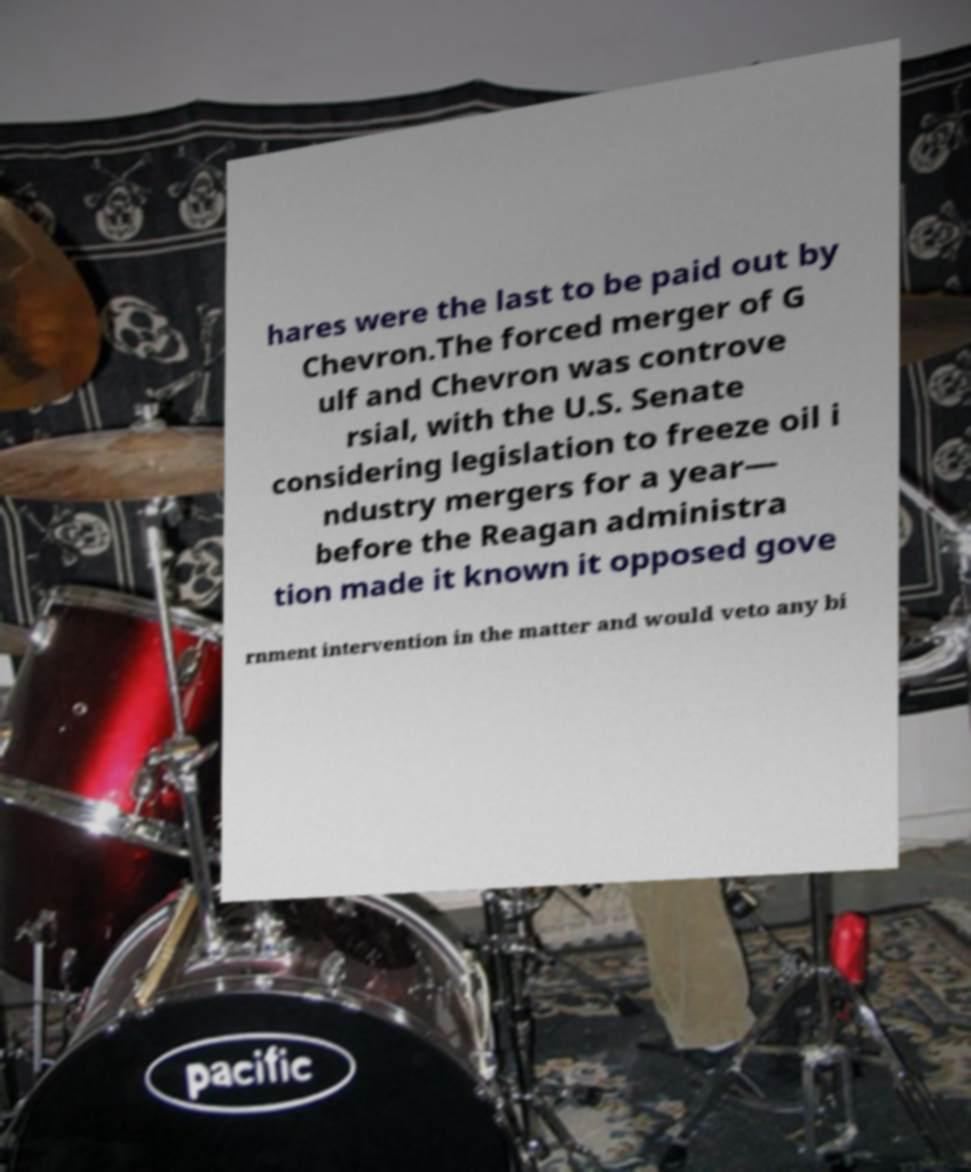I need the written content from this picture converted into text. Can you do that? hares were the last to be paid out by Chevron.The forced merger of G ulf and Chevron was controve rsial, with the U.S. Senate considering legislation to freeze oil i ndustry mergers for a year— before the Reagan administra tion made it known it opposed gove rnment intervention in the matter and would veto any bi 